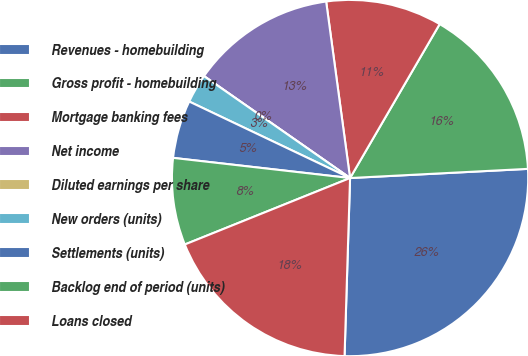<chart> <loc_0><loc_0><loc_500><loc_500><pie_chart><fcel>Revenues - homebuilding<fcel>Gross profit - homebuilding<fcel>Mortgage banking fees<fcel>Net income<fcel>Diluted earnings per share<fcel>New orders (units)<fcel>Settlements (units)<fcel>Backlog end of period (units)<fcel>Loans closed<nl><fcel>26.31%<fcel>15.79%<fcel>10.53%<fcel>13.16%<fcel>0.0%<fcel>2.63%<fcel>5.26%<fcel>7.89%<fcel>18.42%<nl></chart> 